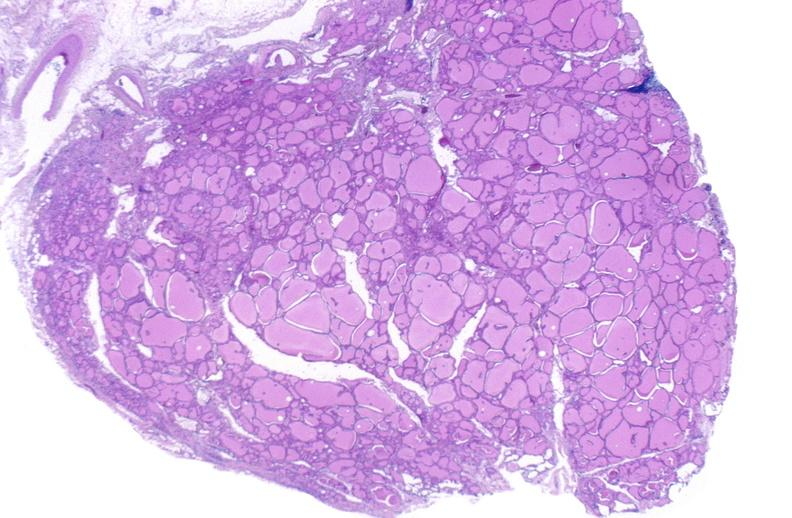s endocrine present?
Answer the question using a single word or phrase. Yes 